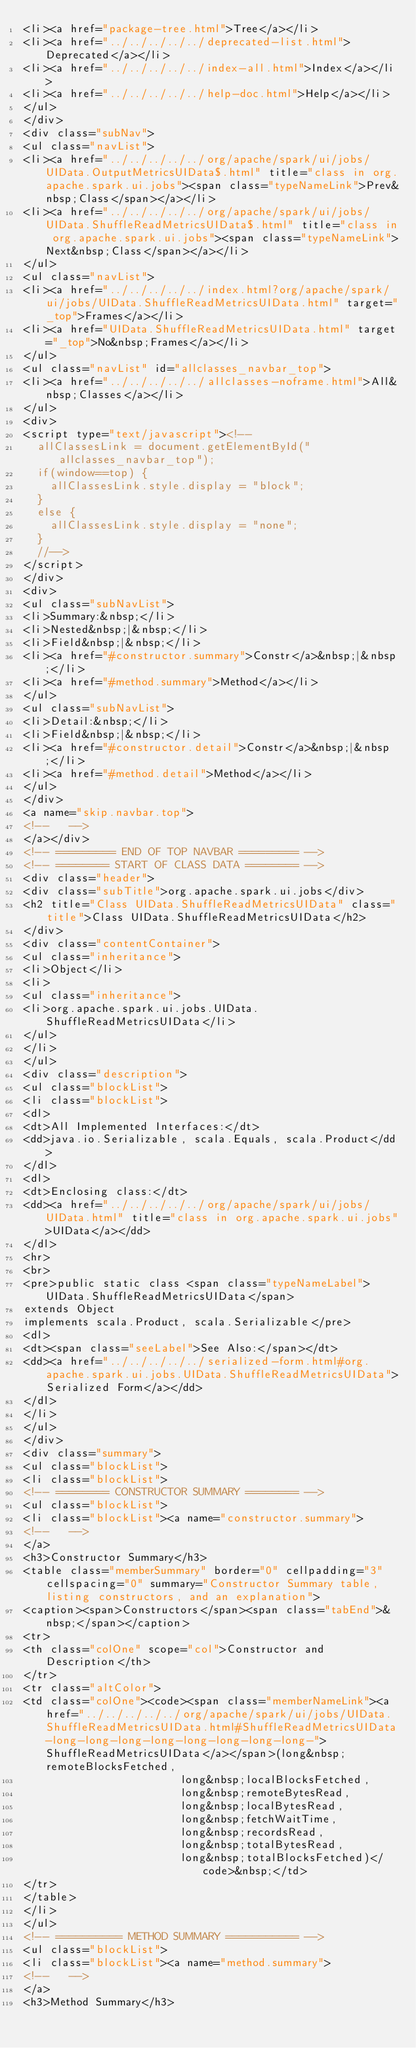<code> <loc_0><loc_0><loc_500><loc_500><_HTML_><li><a href="package-tree.html">Tree</a></li>
<li><a href="../../../../../deprecated-list.html">Deprecated</a></li>
<li><a href="../../../../../index-all.html">Index</a></li>
<li><a href="../../../../../help-doc.html">Help</a></li>
</ul>
</div>
<div class="subNav">
<ul class="navList">
<li><a href="../../../../../org/apache/spark/ui/jobs/UIData.OutputMetricsUIData$.html" title="class in org.apache.spark.ui.jobs"><span class="typeNameLink">Prev&nbsp;Class</span></a></li>
<li><a href="../../../../../org/apache/spark/ui/jobs/UIData.ShuffleReadMetricsUIData$.html" title="class in org.apache.spark.ui.jobs"><span class="typeNameLink">Next&nbsp;Class</span></a></li>
</ul>
<ul class="navList">
<li><a href="../../../../../index.html?org/apache/spark/ui/jobs/UIData.ShuffleReadMetricsUIData.html" target="_top">Frames</a></li>
<li><a href="UIData.ShuffleReadMetricsUIData.html" target="_top">No&nbsp;Frames</a></li>
</ul>
<ul class="navList" id="allclasses_navbar_top">
<li><a href="../../../../../allclasses-noframe.html">All&nbsp;Classes</a></li>
</ul>
<div>
<script type="text/javascript"><!--
  allClassesLink = document.getElementById("allclasses_navbar_top");
  if(window==top) {
    allClassesLink.style.display = "block";
  }
  else {
    allClassesLink.style.display = "none";
  }
  //-->
</script>
</div>
<div>
<ul class="subNavList">
<li>Summary:&nbsp;</li>
<li>Nested&nbsp;|&nbsp;</li>
<li>Field&nbsp;|&nbsp;</li>
<li><a href="#constructor.summary">Constr</a>&nbsp;|&nbsp;</li>
<li><a href="#method.summary">Method</a></li>
</ul>
<ul class="subNavList">
<li>Detail:&nbsp;</li>
<li>Field&nbsp;|&nbsp;</li>
<li><a href="#constructor.detail">Constr</a>&nbsp;|&nbsp;</li>
<li><a href="#method.detail">Method</a></li>
</ul>
</div>
<a name="skip.navbar.top">
<!--   -->
</a></div>
<!-- ========= END OF TOP NAVBAR ========= -->
<!-- ======== START OF CLASS DATA ======== -->
<div class="header">
<div class="subTitle">org.apache.spark.ui.jobs</div>
<h2 title="Class UIData.ShuffleReadMetricsUIData" class="title">Class UIData.ShuffleReadMetricsUIData</h2>
</div>
<div class="contentContainer">
<ul class="inheritance">
<li>Object</li>
<li>
<ul class="inheritance">
<li>org.apache.spark.ui.jobs.UIData.ShuffleReadMetricsUIData</li>
</ul>
</li>
</ul>
<div class="description">
<ul class="blockList">
<li class="blockList">
<dl>
<dt>All Implemented Interfaces:</dt>
<dd>java.io.Serializable, scala.Equals, scala.Product</dd>
</dl>
<dl>
<dt>Enclosing class:</dt>
<dd><a href="../../../../../org/apache/spark/ui/jobs/UIData.html" title="class in org.apache.spark.ui.jobs">UIData</a></dd>
</dl>
<hr>
<br>
<pre>public static class <span class="typeNameLabel">UIData.ShuffleReadMetricsUIData</span>
extends Object
implements scala.Product, scala.Serializable</pre>
<dl>
<dt><span class="seeLabel">See Also:</span></dt>
<dd><a href="../../../../../serialized-form.html#org.apache.spark.ui.jobs.UIData.ShuffleReadMetricsUIData">Serialized Form</a></dd>
</dl>
</li>
</ul>
</div>
<div class="summary">
<ul class="blockList">
<li class="blockList">
<!-- ======== CONSTRUCTOR SUMMARY ======== -->
<ul class="blockList">
<li class="blockList"><a name="constructor.summary">
<!--   -->
</a>
<h3>Constructor Summary</h3>
<table class="memberSummary" border="0" cellpadding="3" cellspacing="0" summary="Constructor Summary table, listing constructors, and an explanation">
<caption><span>Constructors</span><span class="tabEnd">&nbsp;</span></caption>
<tr>
<th class="colOne" scope="col">Constructor and Description</th>
</tr>
<tr class="altColor">
<td class="colOne"><code><span class="memberNameLink"><a href="../../../../../org/apache/spark/ui/jobs/UIData.ShuffleReadMetricsUIData.html#ShuffleReadMetricsUIData-long-long-long-long-long-long-long-long-">ShuffleReadMetricsUIData</a></span>(long&nbsp;remoteBlocksFetched,
                        long&nbsp;localBlocksFetched,
                        long&nbsp;remoteBytesRead,
                        long&nbsp;localBytesRead,
                        long&nbsp;fetchWaitTime,
                        long&nbsp;recordsRead,
                        long&nbsp;totalBytesRead,
                        long&nbsp;totalBlocksFetched)</code>&nbsp;</td>
</tr>
</table>
</li>
</ul>
<!-- ========== METHOD SUMMARY =========== -->
<ul class="blockList">
<li class="blockList"><a name="method.summary">
<!--   -->
</a>
<h3>Method Summary</h3></code> 